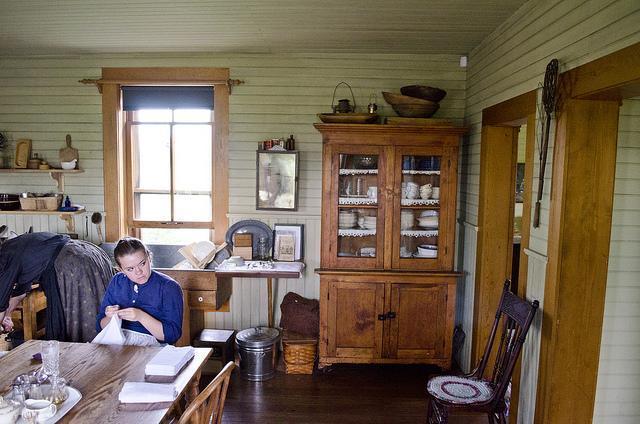How many shades of blue are represented in the ladies' outfits in this picture?
Give a very brief answer. 1. How many people are sitting?
Give a very brief answer. 1. How many people are in the room?
Give a very brief answer. 2. How many windows are in the picture?
Give a very brief answer. 1. How many people are there?
Give a very brief answer. 2. How many donuts are there?
Give a very brief answer. 0. 